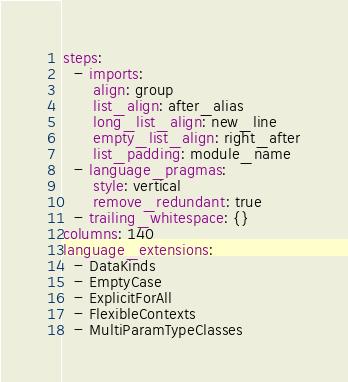<code> <loc_0><loc_0><loc_500><loc_500><_YAML_>steps:
  - imports:
      align: group
      list_align: after_alias
      long_list_align: new_line
      empty_list_align: right_after
      list_padding: module_name
  - language_pragmas:
      style: vertical
      remove_redundant: true
  - trailing_whitespace: {}
columns: 140
language_extensions:
  - DataKinds
  - EmptyCase
  - ExplicitForAll
  - FlexibleContexts
  - MultiParamTypeClasses
</code> 